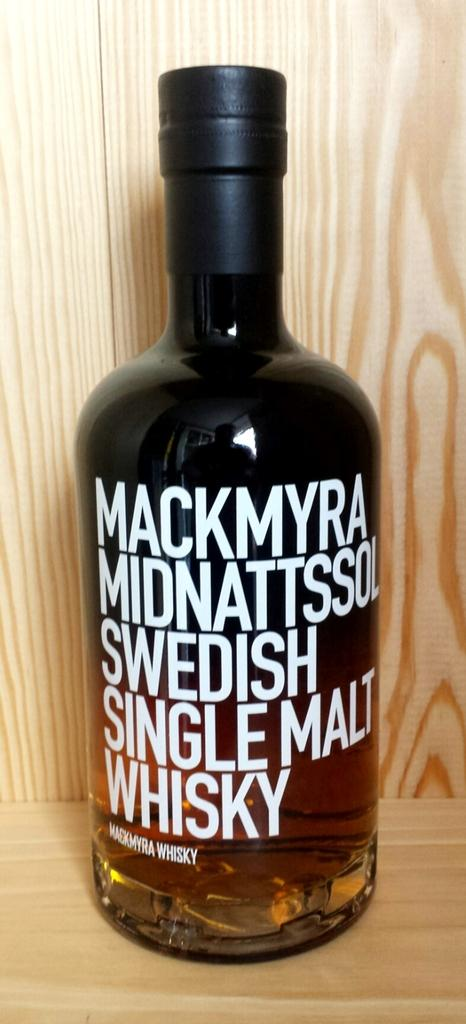<image>
Create a compact narrative representing the image presented. A bottle of Swedish Single Malt Whisky sits on a table 